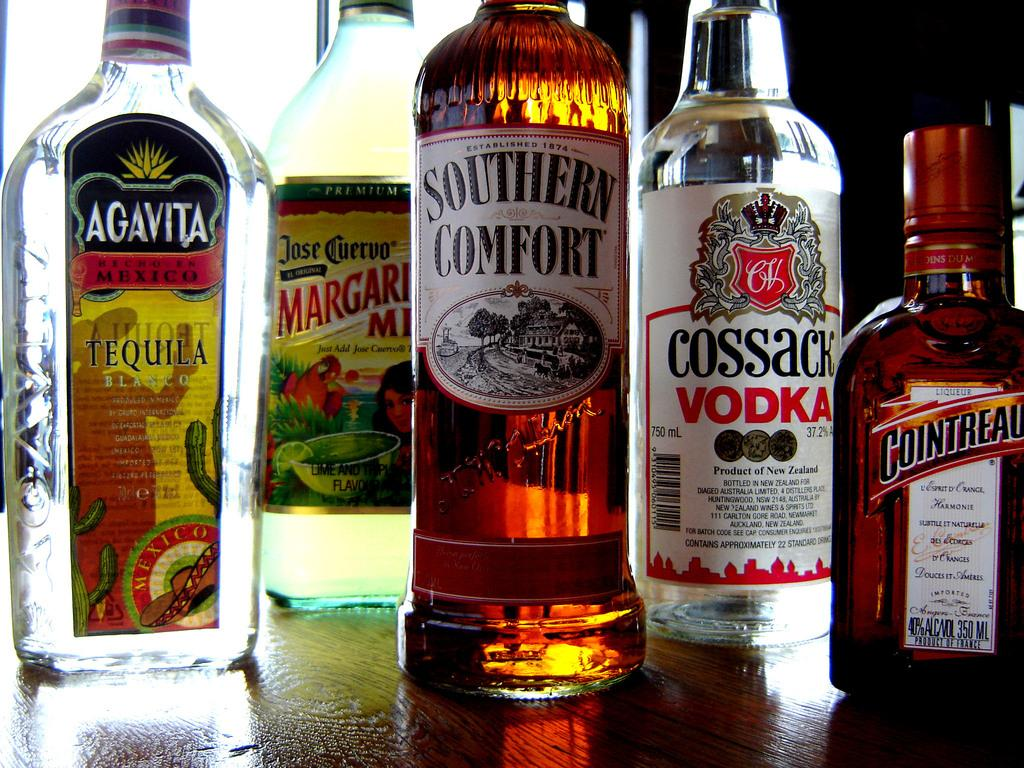<image>
Give a short and clear explanation of the subsequent image. Different types of Spirits like Southern Comfort and Cossack Vodka that are on a shelf. 